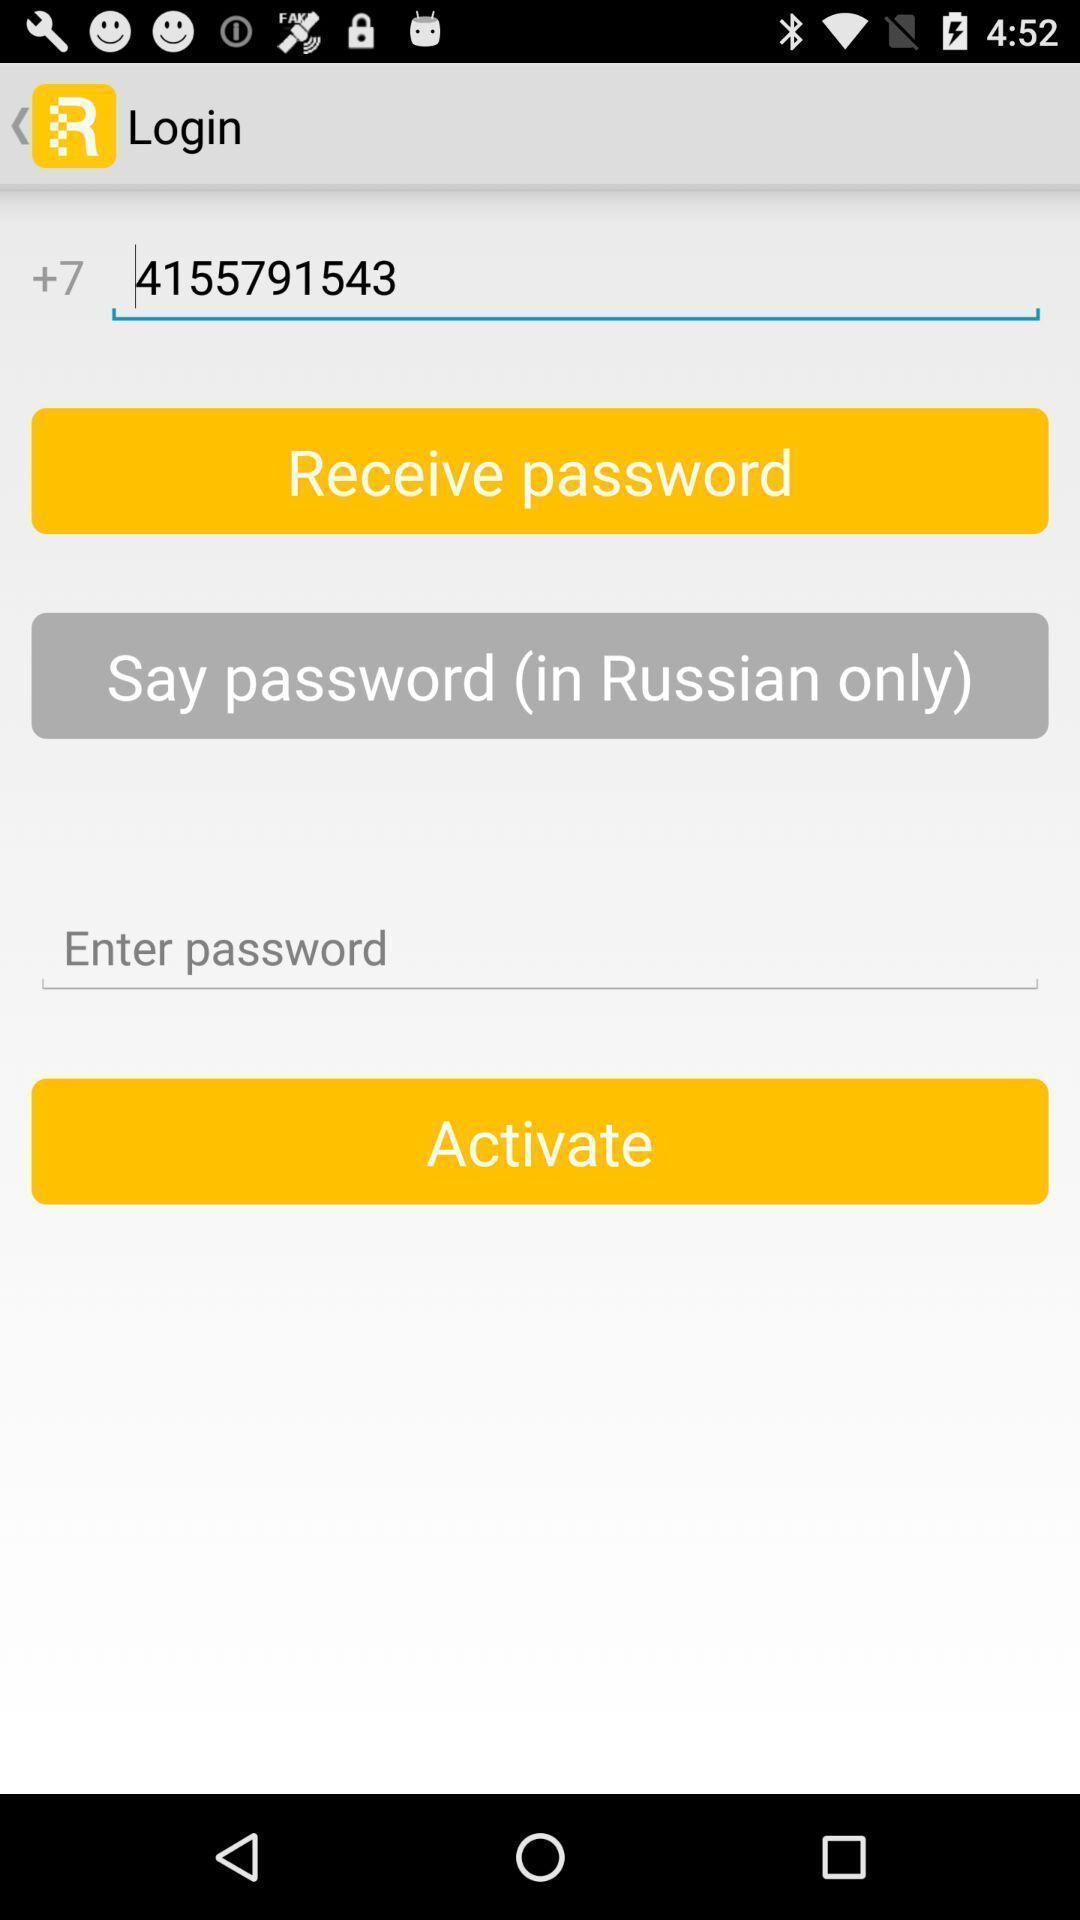Describe this image in words. Screen displaying multiple options in login page. 